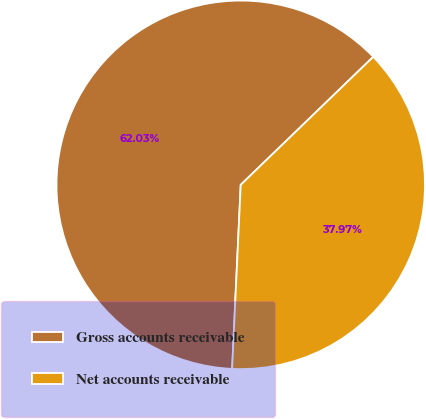Convert chart. <chart><loc_0><loc_0><loc_500><loc_500><pie_chart><fcel>Gross accounts receivable<fcel>Net accounts receivable<nl><fcel>62.03%<fcel>37.97%<nl></chart> 